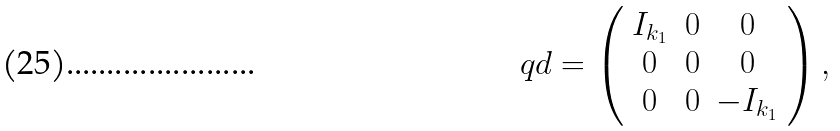<formula> <loc_0><loc_0><loc_500><loc_500>\ q { d } = \left ( \begin{array} { c c c } I _ { k _ { 1 } } & 0 & 0 \\ 0 & 0 & 0 \\ 0 & 0 & - I _ { k _ { 1 } } \end{array} \right ) ,</formula> 